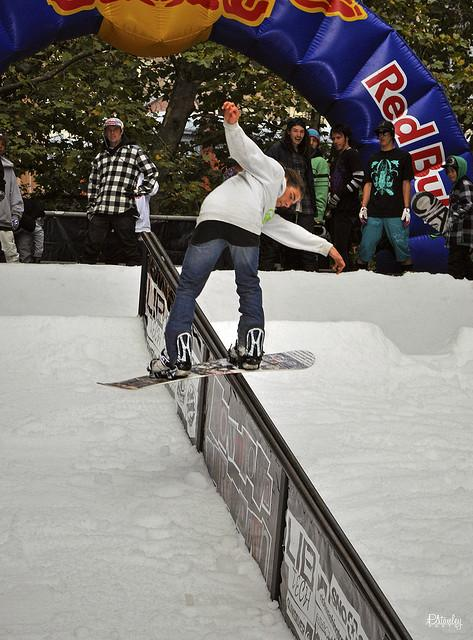What position does this player have the snowboards center point on the rail? Please explain your reasoning. flat. In order for the man to balance they must have the snowboard flat on the pipe. 